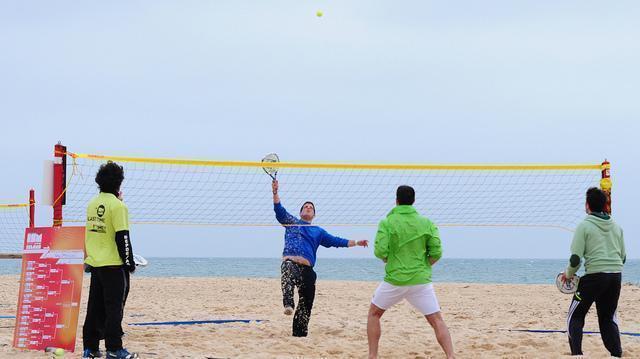What type of net is being played over?
Choose the right answer and clarify with the format: 'Answer: answer
Rationale: rationale.'
Options: Tennis, volleyball, fish, fencing. Answer: volleyball.
Rationale: The people are playing beach volleyball. 